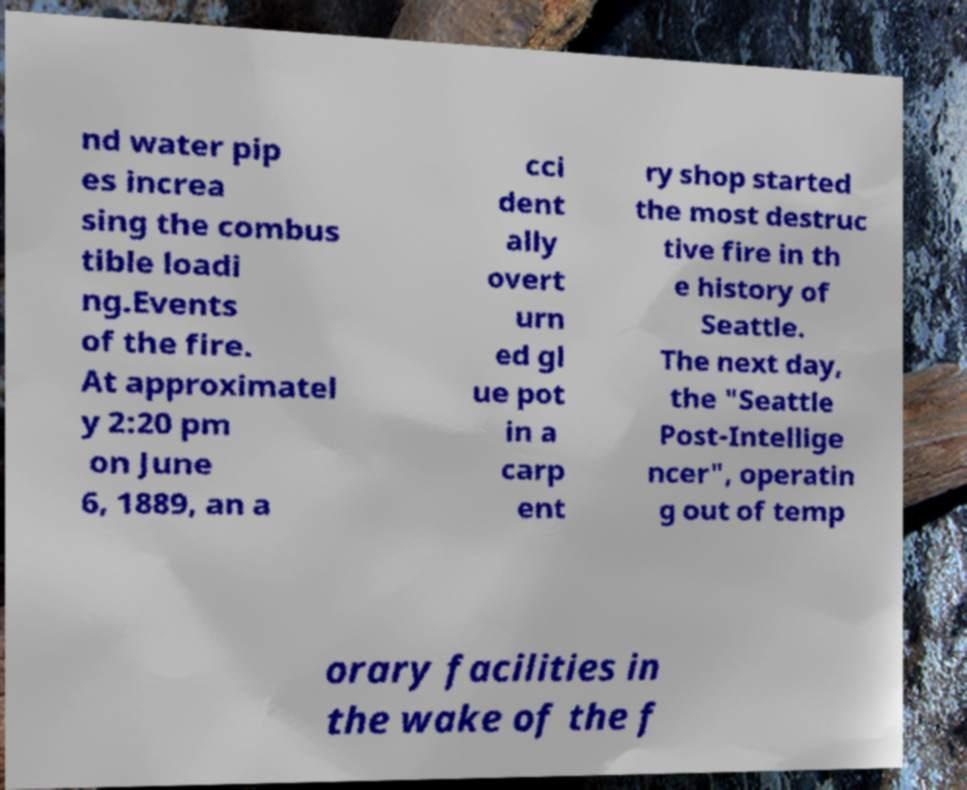I need the written content from this picture converted into text. Can you do that? nd water pip es increa sing the combus tible loadi ng.Events of the fire. At approximatel y 2:20 pm on June 6, 1889, an a cci dent ally overt urn ed gl ue pot in a carp ent ry shop started the most destruc tive fire in th e history of Seattle. The next day, the "Seattle Post-Intellige ncer", operatin g out of temp orary facilities in the wake of the f 